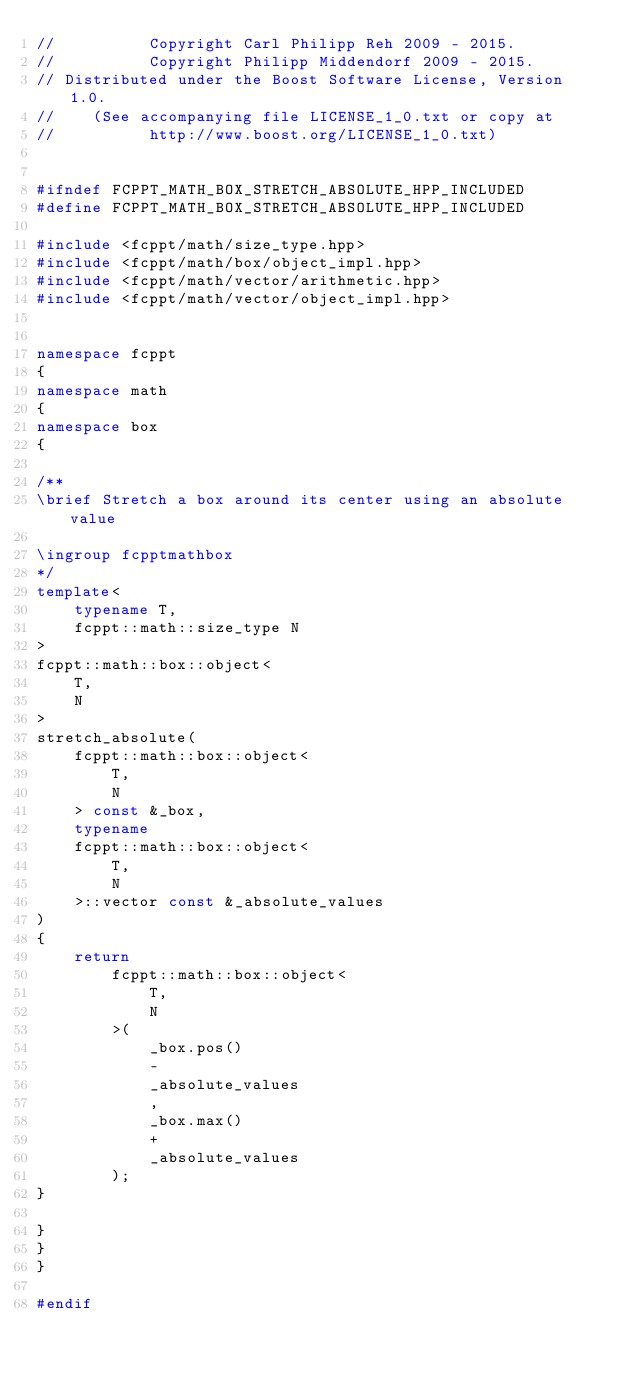Convert code to text. <code><loc_0><loc_0><loc_500><loc_500><_C++_>//          Copyright Carl Philipp Reh 2009 - 2015.
//          Copyright Philipp Middendorf 2009 - 2015.
// Distributed under the Boost Software License, Version 1.0.
//    (See accompanying file LICENSE_1_0.txt or copy at
//          http://www.boost.org/LICENSE_1_0.txt)


#ifndef FCPPT_MATH_BOX_STRETCH_ABSOLUTE_HPP_INCLUDED
#define FCPPT_MATH_BOX_STRETCH_ABSOLUTE_HPP_INCLUDED

#include <fcppt/math/size_type.hpp>
#include <fcppt/math/box/object_impl.hpp>
#include <fcppt/math/vector/arithmetic.hpp>
#include <fcppt/math/vector/object_impl.hpp>


namespace fcppt
{
namespace math
{
namespace box
{

/**
\brief Stretch a box around its center using an absolute value

\ingroup fcpptmathbox
*/
template<
	typename T,
	fcppt::math::size_type N
>
fcppt::math::box::object<
	T,
	N
>
stretch_absolute(
	fcppt::math::box::object<
		T,
		N
	> const &_box,
	typename
	fcppt::math::box::object<
		T,
		N
	>::vector const &_absolute_values
)
{
	return
		fcppt::math::box::object<
			T,
			N
		>(
			_box.pos()
			-
			_absolute_values
			,
			_box.max()
			+
			_absolute_values
		);
}

}
}
}

#endif

</code> 